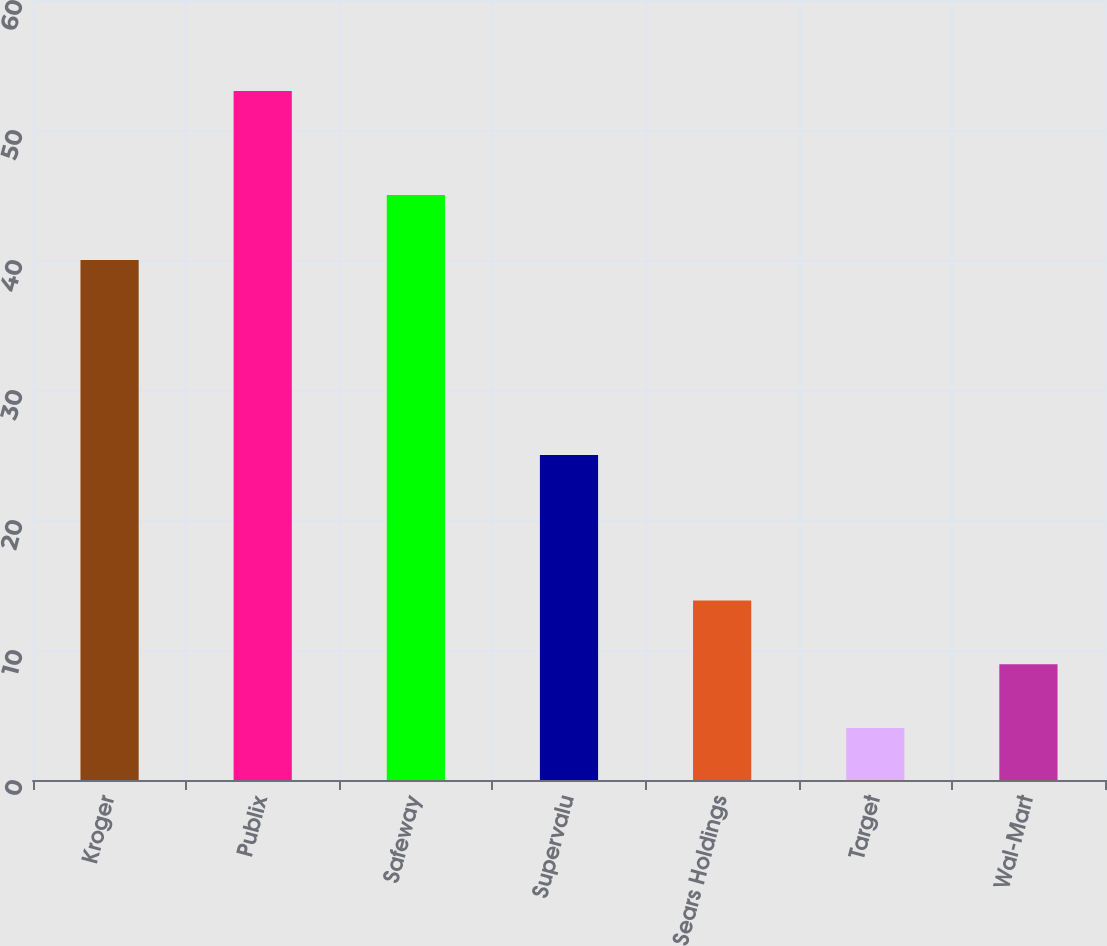Convert chart to OTSL. <chart><loc_0><loc_0><loc_500><loc_500><bar_chart><fcel>Kroger<fcel>Publix<fcel>Safeway<fcel>Supervalu<fcel>Sears Holdings<fcel>Target<fcel>Wal-Mart<nl><fcel>40<fcel>53<fcel>45<fcel>25<fcel>13.8<fcel>4<fcel>8.9<nl></chart> 